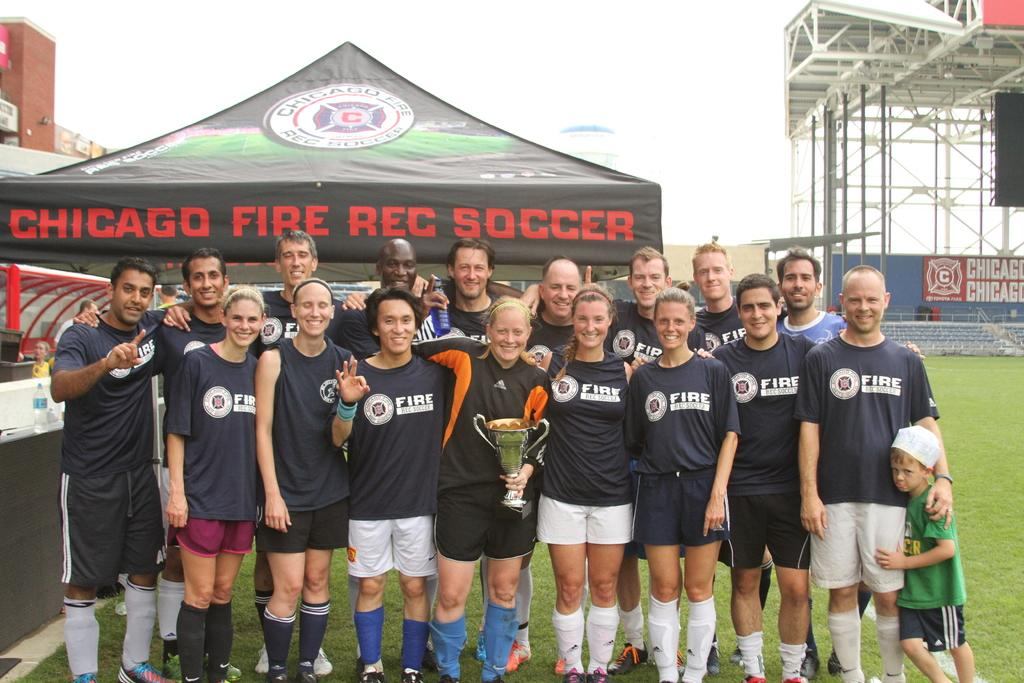<image>
Relay a brief, clear account of the picture shown. The soccer players uniform is made by ADIDAS. 